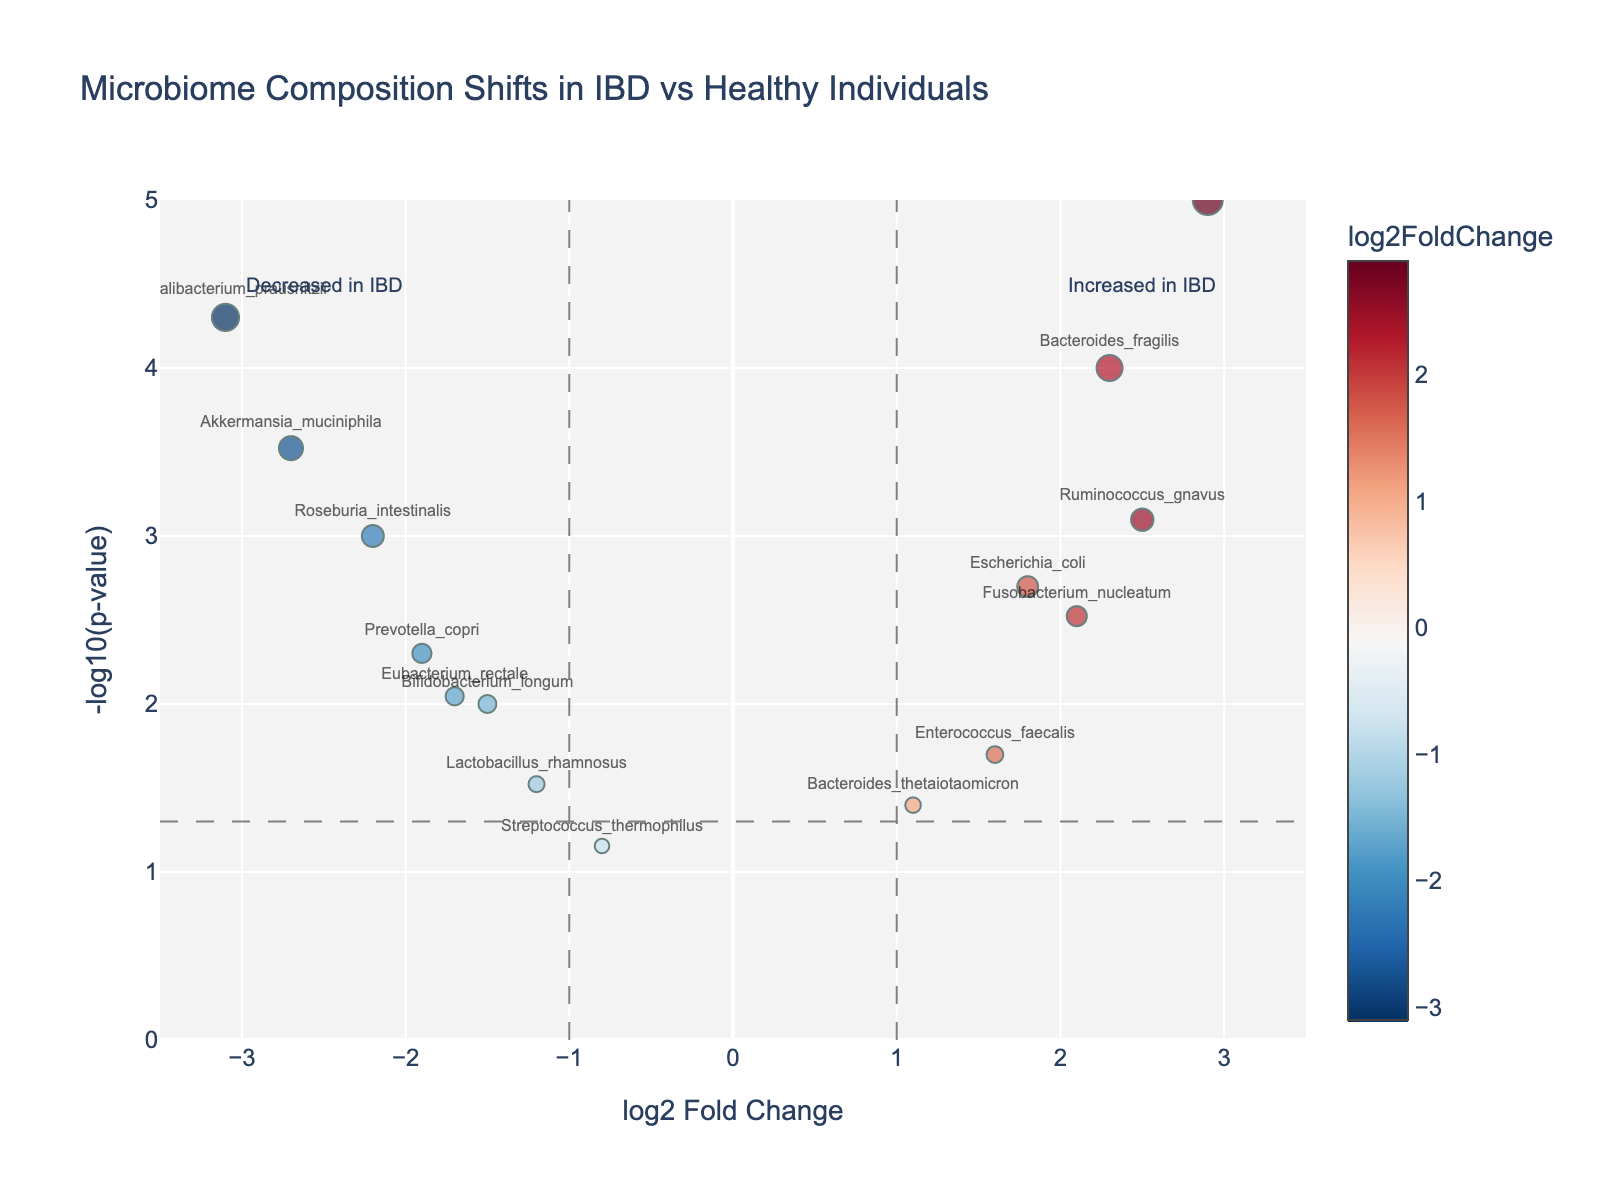How many genes are labeled as increased in IBD? The genes labeled as "increased in IBD" are on the right side of the plot, in the region where log2 Fold Change is positive. Counting these labeled genes on the right side yields 7 genes.
Answer: 7 How many genes showed a statistically significant difference (p-value < 0.05)? Statistically significant differences are highlighted by points above the horizontal dashed line at -log10(p-value) = 1.3. Counting these points, we find 12 genes exceed this threshold.
Answer: 12 Which gene has the highest log2 Fold Change? The gene with the highest log2 Fold Change is the one furthest to the right on the x-axis. Clostridium difficile is the furthest right with a log2 Fold Change of 2.9.
Answer: Clostridium difficile Which gene has the lowest log2 Fold Change? The gene with the lowest log2 Fold Change is the one furthest to the left on the x-axis. Faecalibacterium prausnitzii is furthest left with a log2 Fold Change of -3.1.
Answer: Faecalibacterium prausnitzii How does the overrepresentation of Bacteroides fragilis compare to Enterococcus faecalis? Bacteroides fragilis has a log2 Fold Change of 2.3, while Enterococcus faecalis is 1.6. Bacteroides fragilis has a greater overrepresentation in IBD compared to Enterococcus faecalis.
Answer: Bacteroides fragilis What is the approximate p-value of Akkermansia muciniphila? To find the p-value, convert the y-value of Akkermansia muciniphila (approximately 3.52) back to a p-value: \(10^{-3.52} ≈ 0.0003\).
Answer: 0.0003 Among the genes increased in IBD, which has the smallest p-value? To find this, look at the points on the right side for the one with the highest y-value (indicating the smallest p-value). Clostridium difficile has the highest y-value among the points on the right.
Answer: Clostridium difficile Which gene decreased in IBD has the lowest p-value? The gene on the left side of the plot with the highest y-value indicates it has the lowest p-value. Faecalibacterium prausnitzii has the highest y-value among those on the left.
Answer: Faecalibacterium prausnitzii Are there any genes that show similar log2 Fold Change but different levels of statistical significance? By comparing genes with similar log2 Fold Change but different y-values, Bacteroides fragilis (2.3, -log10(pvalue) ~ 4) and Ruminococcus gnavus (2.5, -log10(pvalue) ~ 3) have similar log2 Fold Change but different levels of significance.
Answer: Bacteroides fragilis and Ruminococcus gnavus Which genes are within the non-significant threshold The figure identifies a non-significant threshold with horizontal and vertical dashed lines. The gene within this space that does not surpass thresholds include Streptococcus thermophilus.
Answer: Streptococcus thermophilus 